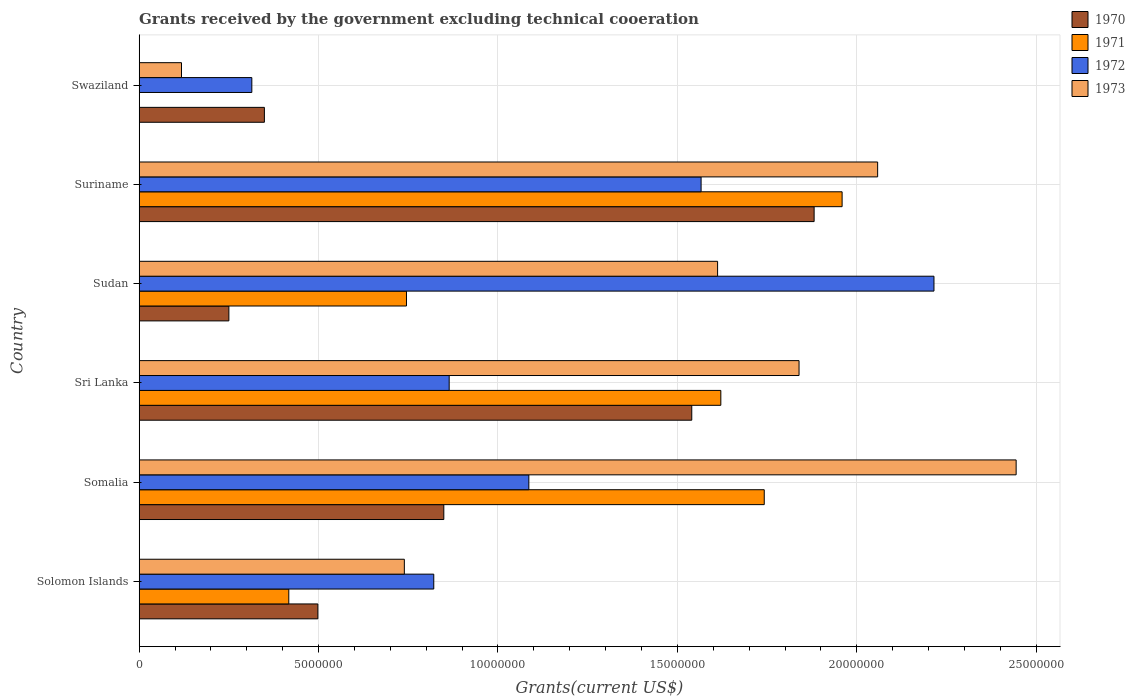How many different coloured bars are there?
Offer a terse response. 4. How many groups of bars are there?
Keep it short and to the point. 6. Are the number of bars on each tick of the Y-axis equal?
Your answer should be very brief. No. How many bars are there on the 2nd tick from the top?
Provide a succinct answer. 4. What is the label of the 4th group of bars from the top?
Provide a succinct answer. Sri Lanka. What is the total grants received by the government in 1970 in Somalia?
Provide a short and direct response. 8.49e+06. Across all countries, what is the maximum total grants received by the government in 1970?
Your answer should be very brief. 1.88e+07. Across all countries, what is the minimum total grants received by the government in 1973?
Your answer should be very brief. 1.18e+06. In which country was the total grants received by the government in 1970 maximum?
Make the answer very short. Suriname. What is the total total grants received by the government in 1972 in the graph?
Give a very brief answer. 6.87e+07. What is the difference between the total grants received by the government in 1970 in Suriname and that in Swaziland?
Your answer should be compact. 1.53e+07. What is the difference between the total grants received by the government in 1973 in Somalia and the total grants received by the government in 1971 in Sri Lanka?
Keep it short and to the point. 8.23e+06. What is the average total grants received by the government in 1973 per country?
Your response must be concise. 1.47e+07. What is the difference between the total grants received by the government in 1972 and total grants received by the government in 1971 in Suriname?
Keep it short and to the point. -3.93e+06. What is the ratio of the total grants received by the government in 1972 in Somalia to that in Suriname?
Offer a terse response. 0.69. Is the total grants received by the government in 1970 in Solomon Islands less than that in Sudan?
Ensure brevity in your answer.  No. What is the difference between the highest and the second highest total grants received by the government in 1970?
Provide a short and direct response. 3.41e+06. What is the difference between the highest and the lowest total grants received by the government in 1973?
Keep it short and to the point. 2.33e+07. In how many countries, is the total grants received by the government in 1972 greater than the average total grants received by the government in 1972 taken over all countries?
Ensure brevity in your answer.  2. Is it the case that in every country, the sum of the total grants received by the government in 1970 and total grants received by the government in 1971 is greater than the sum of total grants received by the government in 1973 and total grants received by the government in 1972?
Provide a short and direct response. No. Is it the case that in every country, the sum of the total grants received by the government in 1970 and total grants received by the government in 1972 is greater than the total grants received by the government in 1973?
Offer a terse response. No. How many bars are there?
Your answer should be compact. 23. Are all the bars in the graph horizontal?
Your answer should be compact. Yes. How many countries are there in the graph?
Keep it short and to the point. 6. Are the values on the major ticks of X-axis written in scientific E-notation?
Provide a short and direct response. No. Does the graph contain grids?
Provide a short and direct response. Yes. How many legend labels are there?
Offer a terse response. 4. How are the legend labels stacked?
Offer a terse response. Vertical. What is the title of the graph?
Offer a terse response. Grants received by the government excluding technical cooeration. Does "1999" appear as one of the legend labels in the graph?
Provide a succinct answer. No. What is the label or title of the X-axis?
Provide a succinct answer. Grants(current US$). What is the Grants(current US$) in 1970 in Solomon Islands?
Offer a terse response. 4.98e+06. What is the Grants(current US$) in 1971 in Solomon Islands?
Ensure brevity in your answer.  4.17e+06. What is the Grants(current US$) of 1972 in Solomon Islands?
Offer a very short reply. 8.21e+06. What is the Grants(current US$) of 1973 in Solomon Islands?
Keep it short and to the point. 7.39e+06. What is the Grants(current US$) in 1970 in Somalia?
Offer a terse response. 8.49e+06. What is the Grants(current US$) in 1971 in Somalia?
Offer a very short reply. 1.74e+07. What is the Grants(current US$) in 1972 in Somalia?
Provide a short and direct response. 1.09e+07. What is the Grants(current US$) in 1973 in Somalia?
Your answer should be very brief. 2.44e+07. What is the Grants(current US$) in 1970 in Sri Lanka?
Keep it short and to the point. 1.54e+07. What is the Grants(current US$) in 1971 in Sri Lanka?
Offer a very short reply. 1.62e+07. What is the Grants(current US$) in 1972 in Sri Lanka?
Your answer should be very brief. 8.64e+06. What is the Grants(current US$) of 1973 in Sri Lanka?
Offer a terse response. 1.84e+07. What is the Grants(current US$) of 1970 in Sudan?
Your answer should be compact. 2.50e+06. What is the Grants(current US$) in 1971 in Sudan?
Your answer should be very brief. 7.45e+06. What is the Grants(current US$) of 1972 in Sudan?
Your answer should be compact. 2.22e+07. What is the Grants(current US$) of 1973 in Sudan?
Ensure brevity in your answer.  1.61e+07. What is the Grants(current US$) of 1970 in Suriname?
Offer a very short reply. 1.88e+07. What is the Grants(current US$) of 1971 in Suriname?
Make the answer very short. 1.96e+07. What is the Grants(current US$) of 1972 in Suriname?
Your answer should be very brief. 1.57e+07. What is the Grants(current US$) of 1973 in Suriname?
Offer a terse response. 2.06e+07. What is the Grants(current US$) of 1970 in Swaziland?
Your answer should be very brief. 3.49e+06. What is the Grants(current US$) in 1971 in Swaziland?
Offer a very short reply. 0. What is the Grants(current US$) of 1972 in Swaziland?
Provide a short and direct response. 3.14e+06. What is the Grants(current US$) of 1973 in Swaziland?
Offer a very short reply. 1.18e+06. Across all countries, what is the maximum Grants(current US$) of 1970?
Your response must be concise. 1.88e+07. Across all countries, what is the maximum Grants(current US$) of 1971?
Keep it short and to the point. 1.96e+07. Across all countries, what is the maximum Grants(current US$) in 1972?
Make the answer very short. 2.22e+07. Across all countries, what is the maximum Grants(current US$) in 1973?
Your answer should be very brief. 2.44e+07. Across all countries, what is the minimum Grants(current US$) of 1970?
Your response must be concise. 2.50e+06. Across all countries, what is the minimum Grants(current US$) of 1971?
Provide a succinct answer. 0. Across all countries, what is the minimum Grants(current US$) of 1972?
Your response must be concise. 3.14e+06. Across all countries, what is the minimum Grants(current US$) of 1973?
Provide a short and direct response. 1.18e+06. What is the total Grants(current US$) of 1970 in the graph?
Provide a succinct answer. 5.37e+07. What is the total Grants(current US$) of 1971 in the graph?
Keep it short and to the point. 6.48e+07. What is the total Grants(current US$) of 1972 in the graph?
Ensure brevity in your answer.  6.87e+07. What is the total Grants(current US$) in 1973 in the graph?
Your answer should be very brief. 8.81e+07. What is the difference between the Grants(current US$) in 1970 in Solomon Islands and that in Somalia?
Make the answer very short. -3.51e+06. What is the difference between the Grants(current US$) of 1971 in Solomon Islands and that in Somalia?
Your response must be concise. -1.32e+07. What is the difference between the Grants(current US$) of 1972 in Solomon Islands and that in Somalia?
Keep it short and to the point. -2.65e+06. What is the difference between the Grants(current US$) of 1973 in Solomon Islands and that in Somalia?
Provide a short and direct response. -1.70e+07. What is the difference between the Grants(current US$) in 1970 in Solomon Islands and that in Sri Lanka?
Provide a succinct answer. -1.04e+07. What is the difference between the Grants(current US$) of 1971 in Solomon Islands and that in Sri Lanka?
Keep it short and to the point. -1.20e+07. What is the difference between the Grants(current US$) in 1972 in Solomon Islands and that in Sri Lanka?
Make the answer very short. -4.30e+05. What is the difference between the Grants(current US$) of 1973 in Solomon Islands and that in Sri Lanka?
Provide a succinct answer. -1.10e+07. What is the difference between the Grants(current US$) in 1970 in Solomon Islands and that in Sudan?
Provide a succinct answer. 2.48e+06. What is the difference between the Grants(current US$) of 1971 in Solomon Islands and that in Sudan?
Offer a very short reply. -3.28e+06. What is the difference between the Grants(current US$) of 1972 in Solomon Islands and that in Sudan?
Offer a terse response. -1.39e+07. What is the difference between the Grants(current US$) in 1973 in Solomon Islands and that in Sudan?
Your response must be concise. -8.73e+06. What is the difference between the Grants(current US$) in 1970 in Solomon Islands and that in Suriname?
Provide a short and direct response. -1.38e+07. What is the difference between the Grants(current US$) in 1971 in Solomon Islands and that in Suriname?
Ensure brevity in your answer.  -1.54e+07. What is the difference between the Grants(current US$) of 1972 in Solomon Islands and that in Suriname?
Keep it short and to the point. -7.45e+06. What is the difference between the Grants(current US$) of 1973 in Solomon Islands and that in Suriname?
Ensure brevity in your answer.  -1.32e+07. What is the difference between the Grants(current US$) of 1970 in Solomon Islands and that in Swaziland?
Your answer should be compact. 1.49e+06. What is the difference between the Grants(current US$) in 1972 in Solomon Islands and that in Swaziland?
Your answer should be compact. 5.07e+06. What is the difference between the Grants(current US$) of 1973 in Solomon Islands and that in Swaziland?
Keep it short and to the point. 6.21e+06. What is the difference between the Grants(current US$) of 1970 in Somalia and that in Sri Lanka?
Make the answer very short. -6.91e+06. What is the difference between the Grants(current US$) in 1971 in Somalia and that in Sri Lanka?
Your response must be concise. 1.21e+06. What is the difference between the Grants(current US$) in 1972 in Somalia and that in Sri Lanka?
Ensure brevity in your answer.  2.22e+06. What is the difference between the Grants(current US$) of 1973 in Somalia and that in Sri Lanka?
Your answer should be compact. 6.05e+06. What is the difference between the Grants(current US$) of 1970 in Somalia and that in Sudan?
Your answer should be very brief. 5.99e+06. What is the difference between the Grants(current US$) of 1971 in Somalia and that in Sudan?
Offer a very short reply. 9.97e+06. What is the difference between the Grants(current US$) of 1972 in Somalia and that in Sudan?
Make the answer very short. -1.13e+07. What is the difference between the Grants(current US$) in 1973 in Somalia and that in Sudan?
Ensure brevity in your answer.  8.32e+06. What is the difference between the Grants(current US$) in 1970 in Somalia and that in Suriname?
Provide a succinct answer. -1.03e+07. What is the difference between the Grants(current US$) in 1971 in Somalia and that in Suriname?
Your answer should be compact. -2.17e+06. What is the difference between the Grants(current US$) of 1972 in Somalia and that in Suriname?
Your response must be concise. -4.80e+06. What is the difference between the Grants(current US$) of 1973 in Somalia and that in Suriname?
Your answer should be very brief. 3.86e+06. What is the difference between the Grants(current US$) of 1972 in Somalia and that in Swaziland?
Ensure brevity in your answer.  7.72e+06. What is the difference between the Grants(current US$) in 1973 in Somalia and that in Swaziland?
Your answer should be very brief. 2.33e+07. What is the difference between the Grants(current US$) in 1970 in Sri Lanka and that in Sudan?
Offer a terse response. 1.29e+07. What is the difference between the Grants(current US$) of 1971 in Sri Lanka and that in Sudan?
Keep it short and to the point. 8.76e+06. What is the difference between the Grants(current US$) of 1972 in Sri Lanka and that in Sudan?
Provide a short and direct response. -1.35e+07. What is the difference between the Grants(current US$) of 1973 in Sri Lanka and that in Sudan?
Provide a succinct answer. 2.27e+06. What is the difference between the Grants(current US$) of 1970 in Sri Lanka and that in Suriname?
Your response must be concise. -3.41e+06. What is the difference between the Grants(current US$) in 1971 in Sri Lanka and that in Suriname?
Your response must be concise. -3.38e+06. What is the difference between the Grants(current US$) of 1972 in Sri Lanka and that in Suriname?
Offer a very short reply. -7.02e+06. What is the difference between the Grants(current US$) of 1973 in Sri Lanka and that in Suriname?
Offer a terse response. -2.19e+06. What is the difference between the Grants(current US$) in 1970 in Sri Lanka and that in Swaziland?
Ensure brevity in your answer.  1.19e+07. What is the difference between the Grants(current US$) in 1972 in Sri Lanka and that in Swaziland?
Give a very brief answer. 5.50e+06. What is the difference between the Grants(current US$) in 1973 in Sri Lanka and that in Swaziland?
Offer a terse response. 1.72e+07. What is the difference between the Grants(current US$) in 1970 in Sudan and that in Suriname?
Keep it short and to the point. -1.63e+07. What is the difference between the Grants(current US$) of 1971 in Sudan and that in Suriname?
Your answer should be very brief. -1.21e+07. What is the difference between the Grants(current US$) in 1972 in Sudan and that in Suriname?
Your answer should be very brief. 6.49e+06. What is the difference between the Grants(current US$) of 1973 in Sudan and that in Suriname?
Make the answer very short. -4.46e+06. What is the difference between the Grants(current US$) of 1970 in Sudan and that in Swaziland?
Provide a succinct answer. -9.90e+05. What is the difference between the Grants(current US$) in 1972 in Sudan and that in Swaziland?
Give a very brief answer. 1.90e+07. What is the difference between the Grants(current US$) in 1973 in Sudan and that in Swaziland?
Ensure brevity in your answer.  1.49e+07. What is the difference between the Grants(current US$) in 1970 in Suriname and that in Swaziland?
Your response must be concise. 1.53e+07. What is the difference between the Grants(current US$) of 1972 in Suriname and that in Swaziland?
Provide a succinct answer. 1.25e+07. What is the difference between the Grants(current US$) in 1973 in Suriname and that in Swaziland?
Keep it short and to the point. 1.94e+07. What is the difference between the Grants(current US$) of 1970 in Solomon Islands and the Grants(current US$) of 1971 in Somalia?
Your answer should be compact. -1.24e+07. What is the difference between the Grants(current US$) of 1970 in Solomon Islands and the Grants(current US$) of 1972 in Somalia?
Provide a succinct answer. -5.88e+06. What is the difference between the Grants(current US$) in 1970 in Solomon Islands and the Grants(current US$) in 1973 in Somalia?
Your answer should be compact. -1.95e+07. What is the difference between the Grants(current US$) in 1971 in Solomon Islands and the Grants(current US$) in 1972 in Somalia?
Give a very brief answer. -6.69e+06. What is the difference between the Grants(current US$) in 1971 in Solomon Islands and the Grants(current US$) in 1973 in Somalia?
Your answer should be compact. -2.03e+07. What is the difference between the Grants(current US$) of 1972 in Solomon Islands and the Grants(current US$) of 1973 in Somalia?
Make the answer very short. -1.62e+07. What is the difference between the Grants(current US$) of 1970 in Solomon Islands and the Grants(current US$) of 1971 in Sri Lanka?
Provide a short and direct response. -1.12e+07. What is the difference between the Grants(current US$) in 1970 in Solomon Islands and the Grants(current US$) in 1972 in Sri Lanka?
Provide a short and direct response. -3.66e+06. What is the difference between the Grants(current US$) in 1970 in Solomon Islands and the Grants(current US$) in 1973 in Sri Lanka?
Your answer should be very brief. -1.34e+07. What is the difference between the Grants(current US$) of 1971 in Solomon Islands and the Grants(current US$) of 1972 in Sri Lanka?
Provide a short and direct response. -4.47e+06. What is the difference between the Grants(current US$) of 1971 in Solomon Islands and the Grants(current US$) of 1973 in Sri Lanka?
Offer a very short reply. -1.42e+07. What is the difference between the Grants(current US$) of 1972 in Solomon Islands and the Grants(current US$) of 1973 in Sri Lanka?
Offer a terse response. -1.02e+07. What is the difference between the Grants(current US$) in 1970 in Solomon Islands and the Grants(current US$) in 1971 in Sudan?
Offer a terse response. -2.47e+06. What is the difference between the Grants(current US$) of 1970 in Solomon Islands and the Grants(current US$) of 1972 in Sudan?
Give a very brief answer. -1.72e+07. What is the difference between the Grants(current US$) in 1970 in Solomon Islands and the Grants(current US$) in 1973 in Sudan?
Ensure brevity in your answer.  -1.11e+07. What is the difference between the Grants(current US$) in 1971 in Solomon Islands and the Grants(current US$) in 1972 in Sudan?
Your answer should be very brief. -1.80e+07. What is the difference between the Grants(current US$) of 1971 in Solomon Islands and the Grants(current US$) of 1973 in Sudan?
Your response must be concise. -1.20e+07. What is the difference between the Grants(current US$) of 1972 in Solomon Islands and the Grants(current US$) of 1973 in Sudan?
Your answer should be very brief. -7.91e+06. What is the difference between the Grants(current US$) of 1970 in Solomon Islands and the Grants(current US$) of 1971 in Suriname?
Your answer should be compact. -1.46e+07. What is the difference between the Grants(current US$) of 1970 in Solomon Islands and the Grants(current US$) of 1972 in Suriname?
Ensure brevity in your answer.  -1.07e+07. What is the difference between the Grants(current US$) in 1970 in Solomon Islands and the Grants(current US$) in 1973 in Suriname?
Your answer should be very brief. -1.56e+07. What is the difference between the Grants(current US$) in 1971 in Solomon Islands and the Grants(current US$) in 1972 in Suriname?
Provide a succinct answer. -1.15e+07. What is the difference between the Grants(current US$) in 1971 in Solomon Islands and the Grants(current US$) in 1973 in Suriname?
Offer a very short reply. -1.64e+07. What is the difference between the Grants(current US$) of 1972 in Solomon Islands and the Grants(current US$) of 1973 in Suriname?
Your answer should be compact. -1.24e+07. What is the difference between the Grants(current US$) in 1970 in Solomon Islands and the Grants(current US$) in 1972 in Swaziland?
Provide a succinct answer. 1.84e+06. What is the difference between the Grants(current US$) of 1970 in Solomon Islands and the Grants(current US$) of 1973 in Swaziland?
Offer a very short reply. 3.80e+06. What is the difference between the Grants(current US$) in 1971 in Solomon Islands and the Grants(current US$) in 1972 in Swaziland?
Your answer should be compact. 1.03e+06. What is the difference between the Grants(current US$) in 1971 in Solomon Islands and the Grants(current US$) in 1973 in Swaziland?
Keep it short and to the point. 2.99e+06. What is the difference between the Grants(current US$) in 1972 in Solomon Islands and the Grants(current US$) in 1973 in Swaziland?
Ensure brevity in your answer.  7.03e+06. What is the difference between the Grants(current US$) of 1970 in Somalia and the Grants(current US$) of 1971 in Sri Lanka?
Offer a very short reply. -7.72e+06. What is the difference between the Grants(current US$) of 1970 in Somalia and the Grants(current US$) of 1972 in Sri Lanka?
Keep it short and to the point. -1.50e+05. What is the difference between the Grants(current US$) in 1970 in Somalia and the Grants(current US$) in 1973 in Sri Lanka?
Offer a very short reply. -9.90e+06. What is the difference between the Grants(current US$) of 1971 in Somalia and the Grants(current US$) of 1972 in Sri Lanka?
Your response must be concise. 8.78e+06. What is the difference between the Grants(current US$) of 1971 in Somalia and the Grants(current US$) of 1973 in Sri Lanka?
Provide a short and direct response. -9.70e+05. What is the difference between the Grants(current US$) in 1972 in Somalia and the Grants(current US$) in 1973 in Sri Lanka?
Ensure brevity in your answer.  -7.53e+06. What is the difference between the Grants(current US$) in 1970 in Somalia and the Grants(current US$) in 1971 in Sudan?
Ensure brevity in your answer.  1.04e+06. What is the difference between the Grants(current US$) of 1970 in Somalia and the Grants(current US$) of 1972 in Sudan?
Your answer should be compact. -1.37e+07. What is the difference between the Grants(current US$) in 1970 in Somalia and the Grants(current US$) in 1973 in Sudan?
Make the answer very short. -7.63e+06. What is the difference between the Grants(current US$) in 1971 in Somalia and the Grants(current US$) in 1972 in Sudan?
Offer a very short reply. -4.73e+06. What is the difference between the Grants(current US$) of 1971 in Somalia and the Grants(current US$) of 1973 in Sudan?
Give a very brief answer. 1.30e+06. What is the difference between the Grants(current US$) in 1972 in Somalia and the Grants(current US$) in 1973 in Sudan?
Ensure brevity in your answer.  -5.26e+06. What is the difference between the Grants(current US$) in 1970 in Somalia and the Grants(current US$) in 1971 in Suriname?
Your answer should be compact. -1.11e+07. What is the difference between the Grants(current US$) in 1970 in Somalia and the Grants(current US$) in 1972 in Suriname?
Provide a short and direct response. -7.17e+06. What is the difference between the Grants(current US$) in 1970 in Somalia and the Grants(current US$) in 1973 in Suriname?
Provide a short and direct response. -1.21e+07. What is the difference between the Grants(current US$) in 1971 in Somalia and the Grants(current US$) in 1972 in Suriname?
Make the answer very short. 1.76e+06. What is the difference between the Grants(current US$) of 1971 in Somalia and the Grants(current US$) of 1973 in Suriname?
Make the answer very short. -3.16e+06. What is the difference between the Grants(current US$) of 1972 in Somalia and the Grants(current US$) of 1973 in Suriname?
Ensure brevity in your answer.  -9.72e+06. What is the difference between the Grants(current US$) in 1970 in Somalia and the Grants(current US$) in 1972 in Swaziland?
Ensure brevity in your answer.  5.35e+06. What is the difference between the Grants(current US$) in 1970 in Somalia and the Grants(current US$) in 1973 in Swaziland?
Keep it short and to the point. 7.31e+06. What is the difference between the Grants(current US$) in 1971 in Somalia and the Grants(current US$) in 1972 in Swaziland?
Ensure brevity in your answer.  1.43e+07. What is the difference between the Grants(current US$) in 1971 in Somalia and the Grants(current US$) in 1973 in Swaziland?
Give a very brief answer. 1.62e+07. What is the difference between the Grants(current US$) of 1972 in Somalia and the Grants(current US$) of 1973 in Swaziland?
Make the answer very short. 9.68e+06. What is the difference between the Grants(current US$) of 1970 in Sri Lanka and the Grants(current US$) of 1971 in Sudan?
Provide a short and direct response. 7.95e+06. What is the difference between the Grants(current US$) in 1970 in Sri Lanka and the Grants(current US$) in 1972 in Sudan?
Your response must be concise. -6.75e+06. What is the difference between the Grants(current US$) in 1970 in Sri Lanka and the Grants(current US$) in 1973 in Sudan?
Your answer should be very brief. -7.20e+05. What is the difference between the Grants(current US$) of 1971 in Sri Lanka and the Grants(current US$) of 1972 in Sudan?
Offer a terse response. -5.94e+06. What is the difference between the Grants(current US$) of 1972 in Sri Lanka and the Grants(current US$) of 1973 in Sudan?
Your response must be concise. -7.48e+06. What is the difference between the Grants(current US$) in 1970 in Sri Lanka and the Grants(current US$) in 1971 in Suriname?
Provide a short and direct response. -4.19e+06. What is the difference between the Grants(current US$) in 1970 in Sri Lanka and the Grants(current US$) in 1972 in Suriname?
Make the answer very short. -2.60e+05. What is the difference between the Grants(current US$) in 1970 in Sri Lanka and the Grants(current US$) in 1973 in Suriname?
Provide a succinct answer. -5.18e+06. What is the difference between the Grants(current US$) in 1971 in Sri Lanka and the Grants(current US$) in 1972 in Suriname?
Give a very brief answer. 5.50e+05. What is the difference between the Grants(current US$) of 1971 in Sri Lanka and the Grants(current US$) of 1973 in Suriname?
Provide a succinct answer. -4.37e+06. What is the difference between the Grants(current US$) in 1972 in Sri Lanka and the Grants(current US$) in 1973 in Suriname?
Make the answer very short. -1.19e+07. What is the difference between the Grants(current US$) in 1970 in Sri Lanka and the Grants(current US$) in 1972 in Swaziland?
Make the answer very short. 1.23e+07. What is the difference between the Grants(current US$) of 1970 in Sri Lanka and the Grants(current US$) of 1973 in Swaziland?
Ensure brevity in your answer.  1.42e+07. What is the difference between the Grants(current US$) in 1971 in Sri Lanka and the Grants(current US$) in 1972 in Swaziland?
Ensure brevity in your answer.  1.31e+07. What is the difference between the Grants(current US$) in 1971 in Sri Lanka and the Grants(current US$) in 1973 in Swaziland?
Make the answer very short. 1.50e+07. What is the difference between the Grants(current US$) of 1972 in Sri Lanka and the Grants(current US$) of 1973 in Swaziland?
Give a very brief answer. 7.46e+06. What is the difference between the Grants(current US$) of 1970 in Sudan and the Grants(current US$) of 1971 in Suriname?
Your answer should be very brief. -1.71e+07. What is the difference between the Grants(current US$) in 1970 in Sudan and the Grants(current US$) in 1972 in Suriname?
Offer a terse response. -1.32e+07. What is the difference between the Grants(current US$) in 1970 in Sudan and the Grants(current US$) in 1973 in Suriname?
Offer a terse response. -1.81e+07. What is the difference between the Grants(current US$) of 1971 in Sudan and the Grants(current US$) of 1972 in Suriname?
Your answer should be very brief. -8.21e+06. What is the difference between the Grants(current US$) in 1971 in Sudan and the Grants(current US$) in 1973 in Suriname?
Keep it short and to the point. -1.31e+07. What is the difference between the Grants(current US$) in 1972 in Sudan and the Grants(current US$) in 1973 in Suriname?
Ensure brevity in your answer.  1.57e+06. What is the difference between the Grants(current US$) in 1970 in Sudan and the Grants(current US$) in 1972 in Swaziland?
Give a very brief answer. -6.40e+05. What is the difference between the Grants(current US$) of 1970 in Sudan and the Grants(current US$) of 1973 in Swaziland?
Offer a terse response. 1.32e+06. What is the difference between the Grants(current US$) of 1971 in Sudan and the Grants(current US$) of 1972 in Swaziland?
Offer a very short reply. 4.31e+06. What is the difference between the Grants(current US$) in 1971 in Sudan and the Grants(current US$) in 1973 in Swaziland?
Your answer should be compact. 6.27e+06. What is the difference between the Grants(current US$) in 1972 in Sudan and the Grants(current US$) in 1973 in Swaziland?
Provide a short and direct response. 2.10e+07. What is the difference between the Grants(current US$) of 1970 in Suriname and the Grants(current US$) of 1972 in Swaziland?
Ensure brevity in your answer.  1.57e+07. What is the difference between the Grants(current US$) of 1970 in Suriname and the Grants(current US$) of 1973 in Swaziland?
Your response must be concise. 1.76e+07. What is the difference between the Grants(current US$) of 1971 in Suriname and the Grants(current US$) of 1972 in Swaziland?
Keep it short and to the point. 1.64e+07. What is the difference between the Grants(current US$) of 1971 in Suriname and the Grants(current US$) of 1973 in Swaziland?
Keep it short and to the point. 1.84e+07. What is the difference between the Grants(current US$) in 1972 in Suriname and the Grants(current US$) in 1973 in Swaziland?
Make the answer very short. 1.45e+07. What is the average Grants(current US$) in 1970 per country?
Keep it short and to the point. 8.94e+06. What is the average Grants(current US$) in 1971 per country?
Offer a very short reply. 1.08e+07. What is the average Grants(current US$) in 1972 per country?
Your answer should be very brief. 1.14e+07. What is the average Grants(current US$) of 1973 per country?
Ensure brevity in your answer.  1.47e+07. What is the difference between the Grants(current US$) of 1970 and Grants(current US$) of 1971 in Solomon Islands?
Your answer should be very brief. 8.10e+05. What is the difference between the Grants(current US$) of 1970 and Grants(current US$) of 1972 in Solomon Islands?
Your response must be concise. -3.23e+06. What is the difference between the Grants(current US$) of 1970 and Grants(current US$) of 1973 in Solomon Islands?
Offer a terse response. -2.41e+06. What is the difference between the Grants(current US$) in 1971 and Grants(current US$) in 1972 in Solomon Islands?
Your response must be concise. -4.04e+06. What is the difference between the Grants(current US$) of 1971 and Grants(current US$) of 1973 in Solomon Islands?
Give a very brief answer. -3.22e+06. What is the difference between the Grants(current US$) in 1972 and Grants(current US$) in 1973 in Solomon Islands?
Keep it short and to the point. 8.20e+05. What is the difference between the Grants(current US$) in 1970 and Grants(current US$) in 1971 in Somalia?
Your response must be concise. -8.93e+06. What is the difference between the Grants(current US$) in 1970 and Grants(current US$) in 1972 in Somalia?
Offer a very short reply. -2.37e+06. What is the difference between the Grants(current US$) in 1970 and Grants(current US$) in 1973 in Somalia?
Keep it short and to the point. -1.60e+07. What is the difference between the Grants(current US$) in 1971 and Grants(current US$) in 1972 in Somalia?
Provide a succinct answer. 6.56e+06. What is the difference between the Grants(current US$) in 1971 and Grants(current US$) in 1973 in Somalia?
Make the answer very short. -7.02e+06. What is the difference between the Grants(current US$) of 1972 and Grants(current US$) of 1973 in Somalia?
Keep it short and to the point. -1.36e+07. What is the difference between the Grants(current US$) of 1970 and Grants(current US$) of 1971 in Sri Lanka?
Provide a succinct answer. -8.10e+05. What is the difference between the Grants(current US$) of 1970 and Grants(current US$) of 1972 in Sri Lanka?
Make the answer very short. 6.76e+06. What is the difference between the Grants(current US$) in 1970 and Grants(current US$) in 1973 in Sri Lanka?
Make the answer very short. -2.99e+06. What is the difference between the Grants(current US$) of 1971 and Grants(current US$) of 1972 in Sri Lanka?
Ensure brevity in your answer.  7.57e+06. What is the difference between the Grants(current US$) of 1971 and Grants(current US$) of 1973 in Sri Lanka?
Keep it short and to the point. -2.18e+06. What is the difference between the Grants(current US$) in 1972 and Grants(current US$) in 1973 in Sri Lanka?
Your answer should be compact. -9.75e+06. What is the difference between the Grants(current US$) in 1970 and Grants(current US$) in 1971 in Sudan?
Your answer should be very brief. -4.95e+06. What is the difference between the Grants(current US$) of 1970 and Grants(current US$) of 1972 in Sudan?
Your answer should be compact. -1.96e+07. What is the difference between the Grants(current US$) of 1970 and Grants(current US$) of 1973 in Sudan?
Keep it short and to the point. -1.36e+07. What is the difference between the Grants(current US$) in 1971 and Grants(current US$) in 1972 in Sudan?
Make the answer very short. -1.47e+07. What is the difference between the Grants(current US$) of 1971 and Grants(current US$) of 1973 in Sudan?
Your answer should be very brief. -8.67e+06. What is the difference between the Grants(current US$) in 1972 and Grants(current US$) in 1973 in Sudan?
Offer a terse response. 6.03e+06. What is the difference between the Grants(current US$) of 1970 and Grants(current US$) of 1971 in Suriname?
Ensure brevity in your answer.  -7.80e+05. What is the difference between the Grants(current US$) in 1970 and Grants(current US$) in 1972 in Suriname?
Your answer should be compact. 3.15e+06. What is the difference between the Grants(current US$) in 1970 and Grants(current US$) in 1973 in Suriname?
Provide a short and direct response. -1.77e+06. What is the difference between the Grants(current US$) of 1971 and Grants(current US$) of 1972 in Suriname?
Provide a short and direct response. 3.93e+06. What is the difference between the Grants(current US$) in 1971 and Grants(current US$) in 1973 in Suriname?
Provide a succinct answer. -9.90e+05. What is the difference between the Grants(current US$) in 1972 and Grants(current US$) in 1973 in Suriname?
Provide a succinct answer. -4.92e+06. What is the difference between the Grants(current US$) of 1970 and Grants(current US$) of 1972 in Swaziland?
Provide a short and direct response. 3.50e+05. What is the difference between the Grants(current US$) of 1970 and Grants(current US$) of 1973 in Swaziland?
Provide a succinct answer. 2.31e+06. What is the difference between the Grants(current US$) of 1972 and Grants(current US$) of 1973 in Swaziland?
Ensure brevity in your answer.  1.96e+06. What is the ratio of the Grants(current US$) in 1970 in Solomon Islands to that in Somalia?
Keep it short and to the point. 0.59. What is the ratio of the Grants(current US$) of 1971 in Solomon Islands to that in Somalia?
Your answer should be very brief. 0.24. What is the ratio of the Grants(current US$) of 1972 in Solomon Islands to that in Somalia?
Make the answer very short. 0.76. What is the ratio of the Grants(current US$) in 1973 in Solomon Islands to that in Somalia?
Provide a succinct answer. 0.3. What is the ratio of the Grants(current US$) in 1970 in Solomon Islands to that in Sri Lanka?
Provide a succinct answer. 0.32. What is the ratio of the Grants(current US$) in 1971 in Solomon Islands to that in Sri Lanka?
Offer a terse response. 0.26. What is the ratio of the Grants(current US$) of 1972 in Solomon Islands to that in Sri Lanka?
Keep it short and to the point. 0.95. What is the ratio of the Grants(current US$) of 1973 in Solomon Islands to that in Sri Lanka?
Offer a terse response. 0.4. What is the ratio of the Grants(current US$) in 1970 in Solomon Islands to that in Sudan?
Provide a short and direct response. 1.99. What is the ratio of the Grants(current US$) in 1971 in Solomon Islands to that in Sudan?
Give a very brief answer. 0.56. What is the ratio of the Grants(current US$) in 1972 in Solomon Islands to that in Sudan?
Offer a terse response. 0.37. What is the ratio of the Grants(current US$) of 1973 in Solomon Islands to that in Sudan?
Provide a short and direct response. 0.46. What is the ratio of the Grants(current US$) of 1970 in Solomon Islands to that in Suriname?
Your response must be concise. 0.26. What is the ratio of the Grants(current US$) in 1971 in Solomon Islands to that in Suriname?
Keep it short and to the point. 0.21. What is the ratio of the Grants(current US$) in 1972 in Solomon Islands to that in Suriname?
Keep it short and to the point. 0.52. What is the ratio of the Grants(current US$) of 1973 in Solomon Islands to that in Suriname?
Provide a short and direct response. 0.36. What is the ratio of the Grants(current US$) in 1970 in Solomon Islands to that in Swaziland?
Keep it short and to the point. 1.43. What is the ratio of the Grants(current US$) of 1972 in Solomon Islands to that in Swaziland?
Your answer should be very brief. 2.61. What is the ratio of the Grants(current US$) in 1973 in Solomon Islands to that in Swaziland?
Your response must be concise. 6.26. What is the ratio of the Grants(current US$) in 1970 in Somalia to that in Sri Lanka?
Offer a very short reply. 0.55. What is the ratio of the Grants(current US$) in 1971 in Somalia to that in Sri Lanka?
Give a very brief answer. 1.07. What is the ratio of the Grants(current US$) in 1972 in Somalia to that in Sri Lanka?
Your answer should be very brief. 1.26. What is the ratio of the Grants(current US$) in 1973 in Somalia to that in Sri Lanka?
Your answer should be compact. 1.33. What is the ratio of the Grants(current US$) of 1970 in Somalia to that in Sudan?
Your answer should be very brief. 3.4. What is the ratio of the Grants(current US$) in 1971 in Somalia to that in Sudan?
Ensure brevity in your answer.  2.34. What is the ratio of the Grants(current US$) in 1972 in Somalia to that in Sudan?
Keep it short and to the point. 0.49. What is the ratio of the Grants(current US$) in 1973 in Somalia to that in Sudan?
Your response must be concise. 1.52. What is the ratio of the Grants(current US$) in 1970 in Somalia to that in Suriname?
Offer a terse response. 0.45. What is the ratio of the Grants(current US$) of 1971 in Somalia to that in Suriname?
Your answer should be compact. 0.89. What is the ratio of the Grants(current US$) in 1972 in Somalia to that in Suriname?
Give a very brief answer. 0.69. What is the ratio of the Grants(current US$) in 1973 in Somalia to that in Suriname?
Keep it short and to the point. 1.19. What is the ratio of the Grants(current US$) of 1970 in Somalia to that in Swaziland?
Offer a terse response. 2.43. What is the ratio of the Grants(current US$) of 1972 in Somalia to that in Swaziland?
Offer a terse response. 3.46. What is the ratio of the Grants(current US$) of 1973 in Somalia to that in Swaziland?
Offer a terse response. 20.71. What is the ratio of the Grants(current US$) of 1970 in Sri Lanka to that in Sudan?
Your answer should be very brief. 6.16. What is the ratio of the Grants(current US$) of 1971 in Sri Lanka to that in Sudan?
Your answer should be very brief. 2.18. What is the ratio of the Grants(current US$) of 1972 in Sri Lanka to that in Sudan?
Ensure brevity in your answer.  0.39. What is the ratio of the Grants(current US$) in 1973 in Sri Lanka to that in Sudan?
Make the answer very short. 1.14. What is the ratio of the Grants(current US$) in 1970 in Sri Lanka to that in Suriname?
Provide a short and direct response. 0.82. What is the ratio of the Grants(current US$) in 1971 in Sri Lanka to that in Suriname?
Offer a very short reply. 0.83. What is the ratio of the Grants(current US$) of 1972 in Sri Lanka to that in Suriname?
Offer a very short reply. 0.55. What is the ratio of the Grants(current US$) in 1973 in Sri Lanka to that in Suriname?
Give a very brief answer. 0.89. What is the ratio of the Grants(current US$) in 1970 in Sri Lanka to that in Swaziland?
Ensure brevity in your answer.  4.41. What is the ratio of the Grants(current US$) of 1972 in Sri Lanka to that in Swaziland?
Your answer should be compact. 2.75. What is the ratio of the Grants(current US$) in 1973 in Sri Lanka to that in Swaziland?
Your response must be concise. 15.58. What is the ratio of the Grants(current US$) of 1970 in Sudan to that in Suriname?
Keep it short and to the point. 0.13. What is the ratio of the Grants(current US$) in 1971 in Sudan to that in Suriname?
Make the answer very short. 0.38. What is the ratio of the Grants(current US$) of 1972 in Sudan to that in Suriname?
Ensure brevity in your answer.  1.41. What is the ratio of the Grants(current US$) of 1973 in Sudan to that in Suriname?
Make the answer very short. 0.78. What is the ratio of the Grants(current US$) of 1970 in Sudan to that in Swaziland?
Keep it short and to the point. 0.72. What is the ratio of the Grants(current US$) of 1972 in Sudan to that in Swaziland?
Provide a short and direct response. 7.05. What is the ratio of the Grants(current US$) in 1973 in Sudan to that in Swaziland?
Your answer should be compact. 13.66. What is the ratio of the Grants(current US$) of 1970 in Suriname to that in Swaziland?
Your answer should be very brief. 5.39. What is the ratio of the Grants(current US$) in 1972 in Suriname to that in Swaziland?
Your answer should be very brief. 4.99. What is the ratio of the Grants(current US$) of 1973 in Suriname to that in Swaziland?
Offer a terse response. 17.44. What is the difference between the highest and the second highest Grants(current US$) in 1970?
Keep it short and to the point. 3.41e+06. What is the difference between the highest and the second highest Grants(current US$) of 1971?
Make the answer very short. 2.17e+06. What is the difference between the highest and the second highest Grants(current US$) of 1972?
Offer a terse response. 6.49e+06. What is the difference between the highest and the second highest Grants(current US$) of 1973?
Provide a succinct answer. 3.86e+06. What is the difference between the highest and the lowest Grants(current US$) in 1970?
Your response must be concise. 1.63e+07. What is the difference between the highest and the lowest Grants(current US$) in 1971?
Provide a succinct answer. 1.96e+07. What is the difference between the highest and the lowest Grants(current US$) in 1972?
Provide a short and direct response. 1.90e+07. What is the difference between the highest and the lowest Grants(current US$) of 1973?
Ensure brevity in your answer.  2.33e+07. 